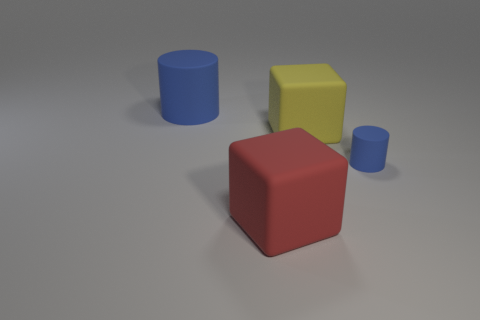There is a rubber cylinder that is on the right side of the blue cylinder that is behind the small object; is there a rubber cube on the left side of it?
Keep it short and to the point. Yes. Is there any other thing that is the same shape as the yellow rubber object?
Provide a short and direct response. Yes. There is a matte cylinder behind the tiny blue thing; is its color the same as the matte cylinder that is to the right of the large blue cylinder?
Your answer should be compact. Yes. Are there any big brown metallic things?
Provide a short and direct response. No. There is a blue thing on the right side of the big cube that is behind the blue cylinder in front of the big blue cylinder; how big is it?
Your answer should be compact. Small. There is a red object; is its shape the same as the yellow thing that is behind the big red thing?
Keep it short and to the point. Yes. Are there any other cylinders of the same color as the large rubber cylinder?
Make the answer very short. Yes. How many cylinders are tiny matte objects or blue rubber objects?
Your response must be concise. 2. Is there a large object of the same shape as the tiny blue object?
Make the answer very short. Yes. What number of other things are there of the same color as the small matte thing?
Offer a terse response. 1. 